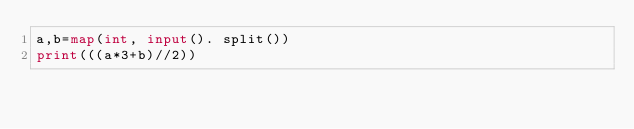<code> <loc_0><loc_0><loc_500><loc_500><_Python_>a,b=map(int, input(). split())
print(((a*3+b)//2))</code> 